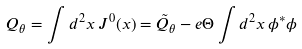Convert formula to latex. <formula><loc_0><loc_0><loc_500><loc_500>Q _ { \theta } = \int d ^ { 2 } x \, J ^ { 0 } ( x ) = \tilde { Q } _ { \theta } - e \Theta \int d ^ { 2 } x \, \phi ^ { * } \phi</formula> 